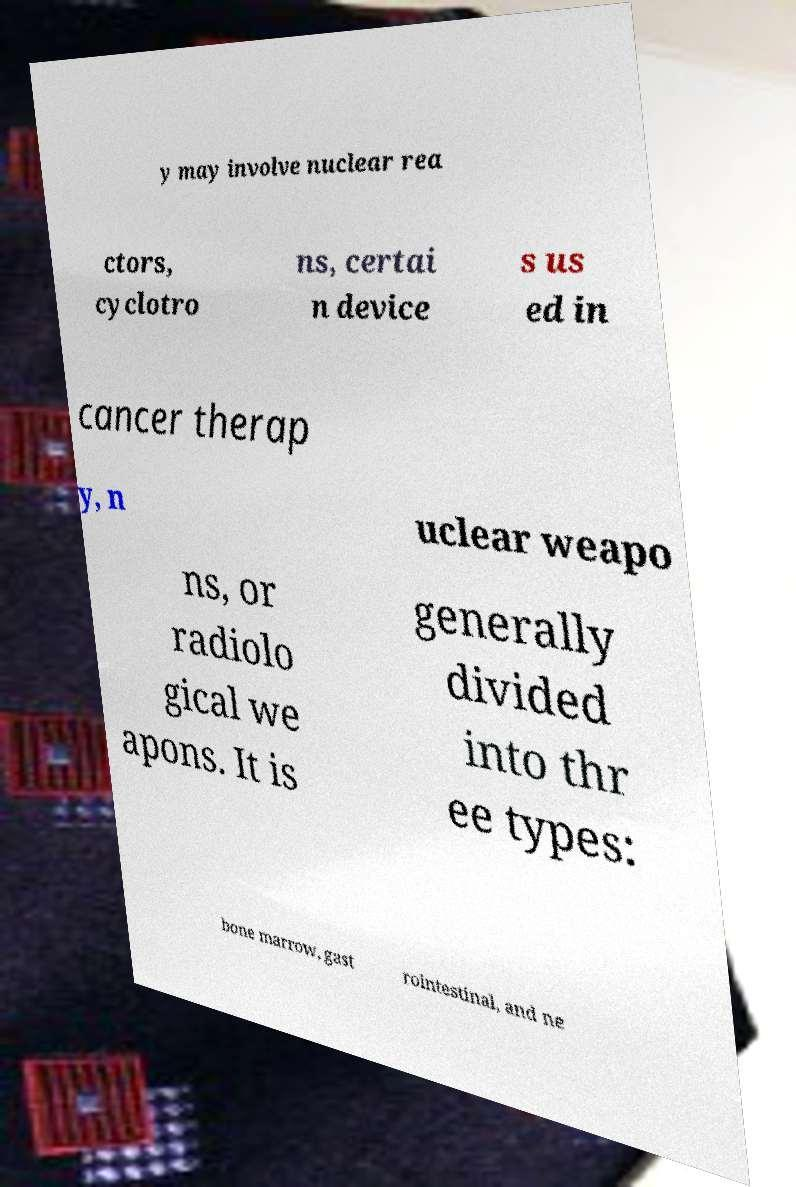For documentation purposes, I need the text within this image transcribed. Could you provide that? y may involve nuclear rea ctors, cyclotro ns, certai n device s us ed in cancer therap y, n uclear weapo ns, or radiolo gical we apons. It is generally divided into thr ee types: bone marrow, gast rointestinal, and ne 